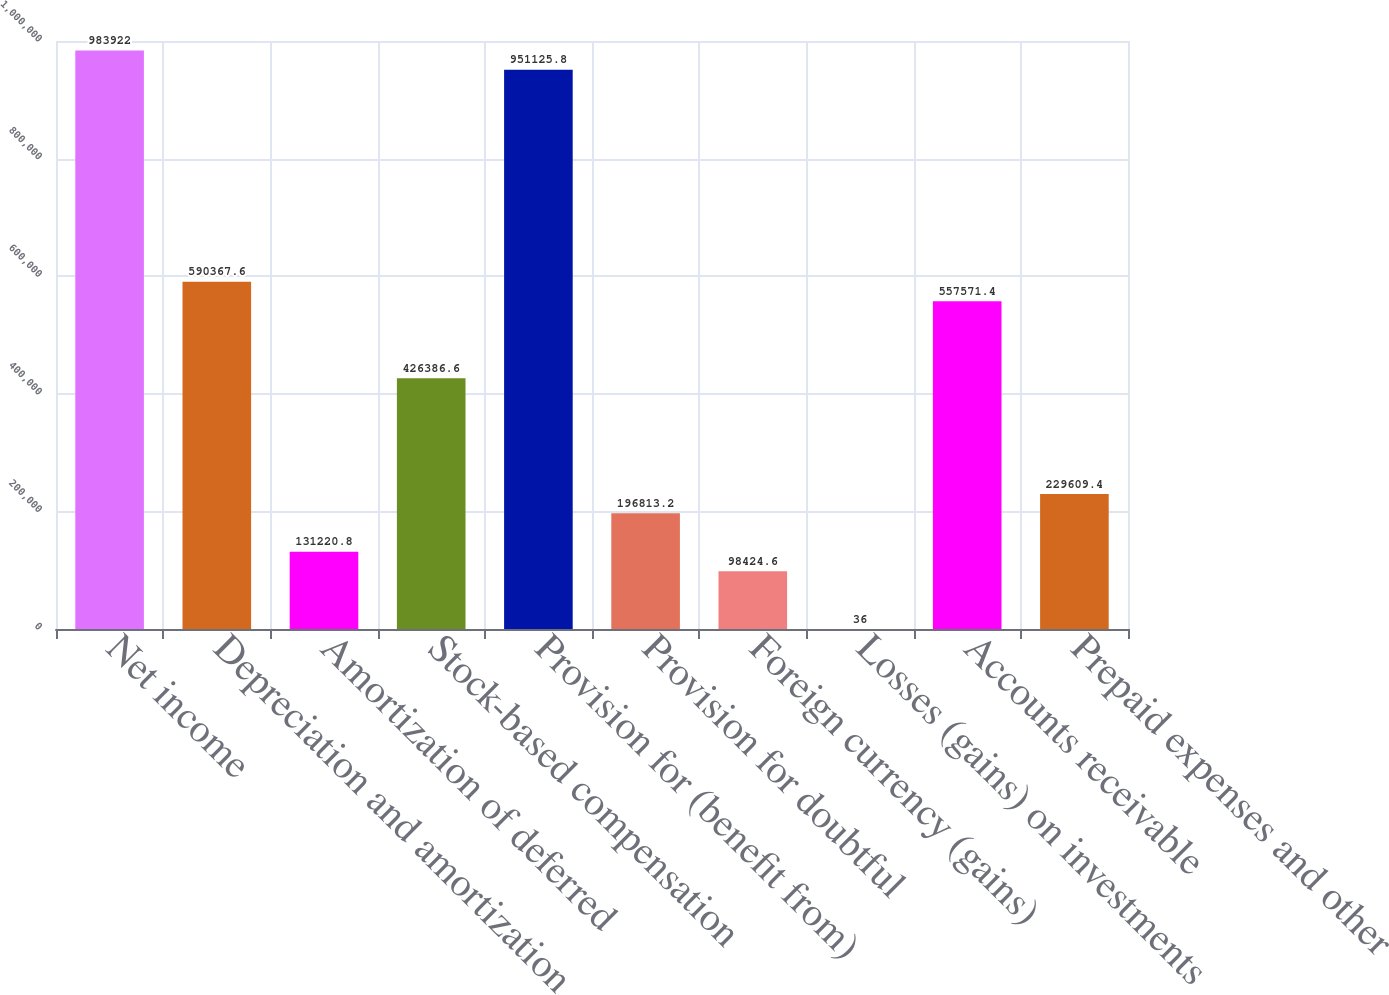Convert chart to OTSL. <chart><loc_0><loc_0><loc_500><loc_500><bar_chart><fcel>Net income<fcel>Depreciation and amortization<fcel>Amortization of deferred<fcel>Stock-based compensation<fcel>Provision for (benefit from)<fcel>Provision for doubtful<fcel>Foreign currency (gains)<fcel>Losses (gains) on investments<fcel>Accounts receivable<fcel>Prepaid expenses and other<nl><fcel>983922<fcel>590368<fcel>131221<fcel>426387<fcel>951126<fcel>196813<fcel>98424.6<fcel>36<fcel>557571<fcel>229609<nl></chart> 